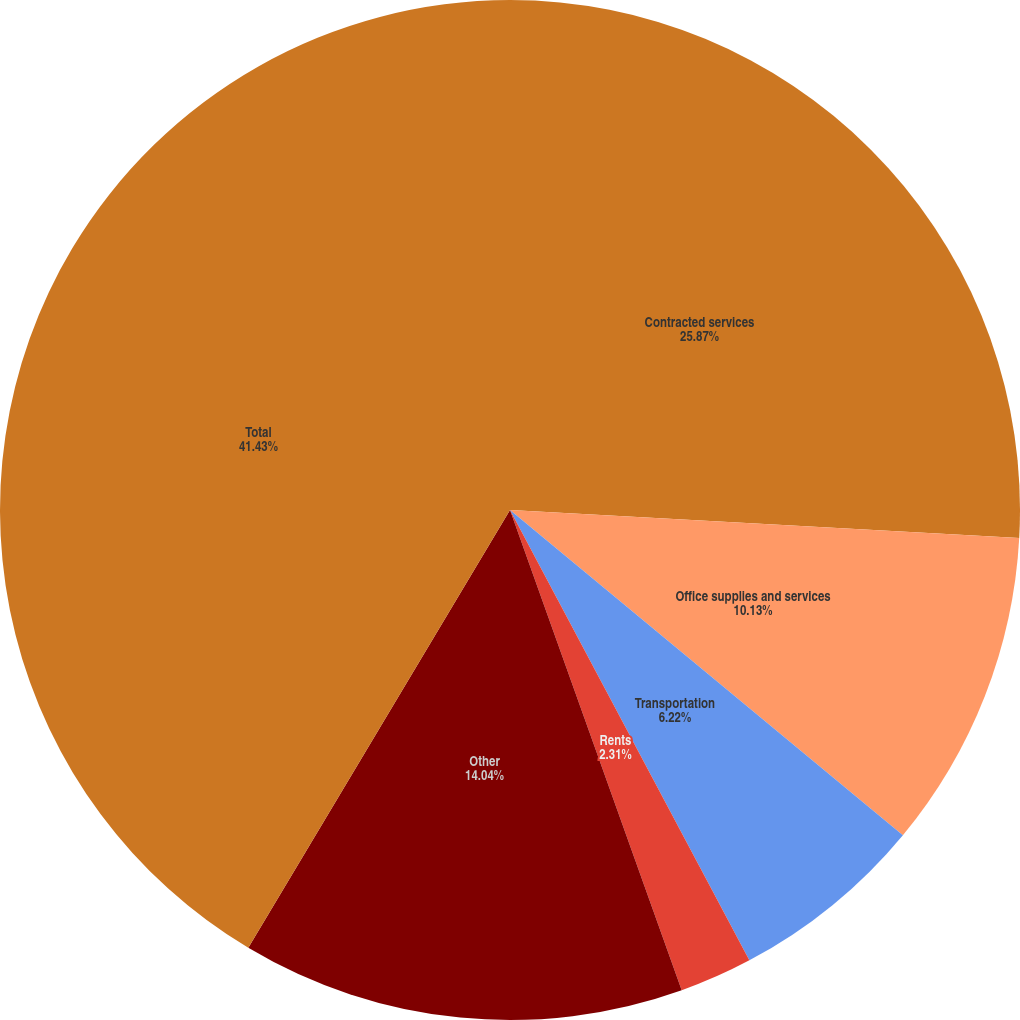Convert chart. <chart><loc_0><loc_0><loc_500><loc_500><pie_chart><fcel>Contracted services<fcel>Office supplies and services<fcel>Transportation<fcel>Rents<fcel>Other<fcel>Total<nl><fcel>25.87%<fcel>10.13%<fcel>6.22%<fcel>2.31%<fcel>14.04%<fcel>41.42%<nl></chart> 